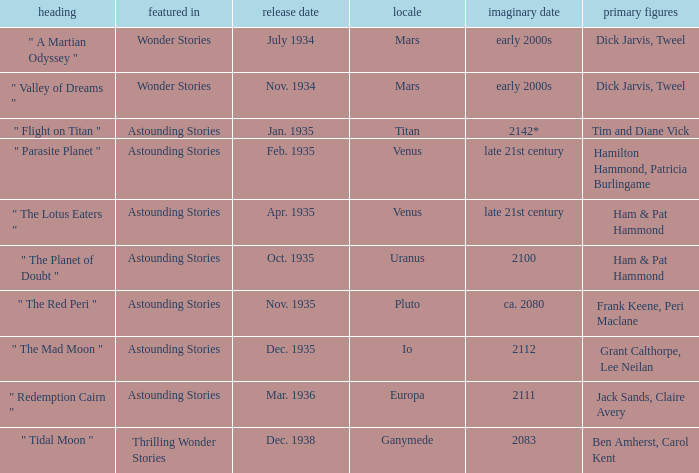Name the title when the main characters are grant calthorpe, lee neilan and the published in of astounding stories " The Mad Moon ". 